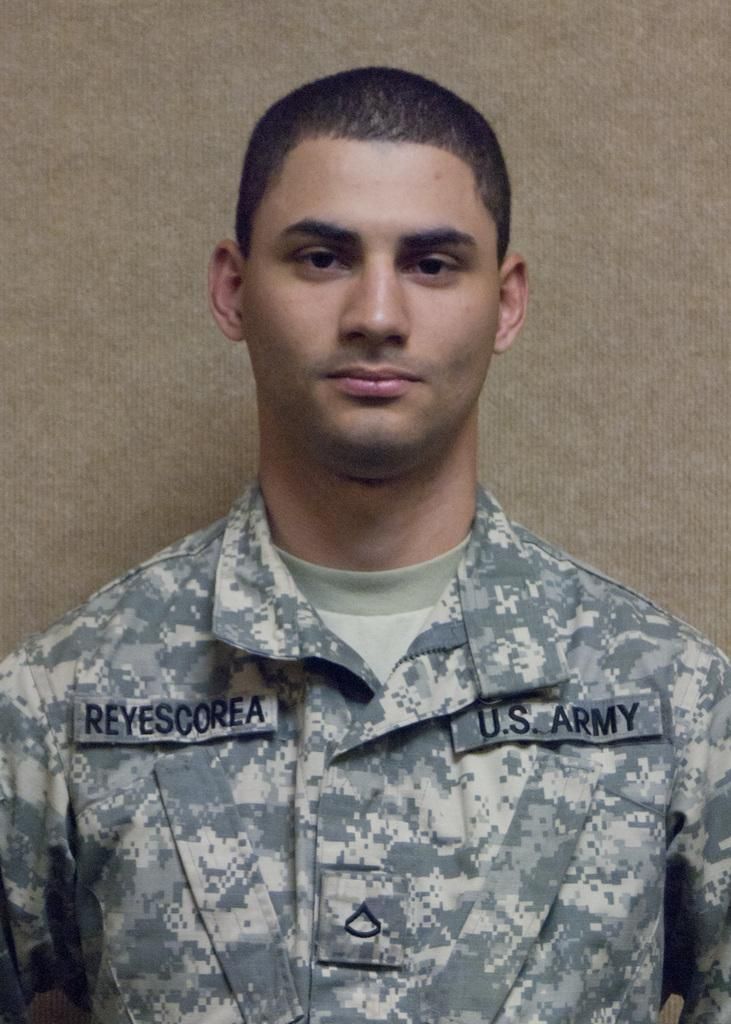What is present in the image? There is a man in the image. Can you describe any additional details about the man? There is text visible on the man's shirt. How many cherries are on the man's shirt in the image? There is no mention of cherries in the image or on the man's shirt. 